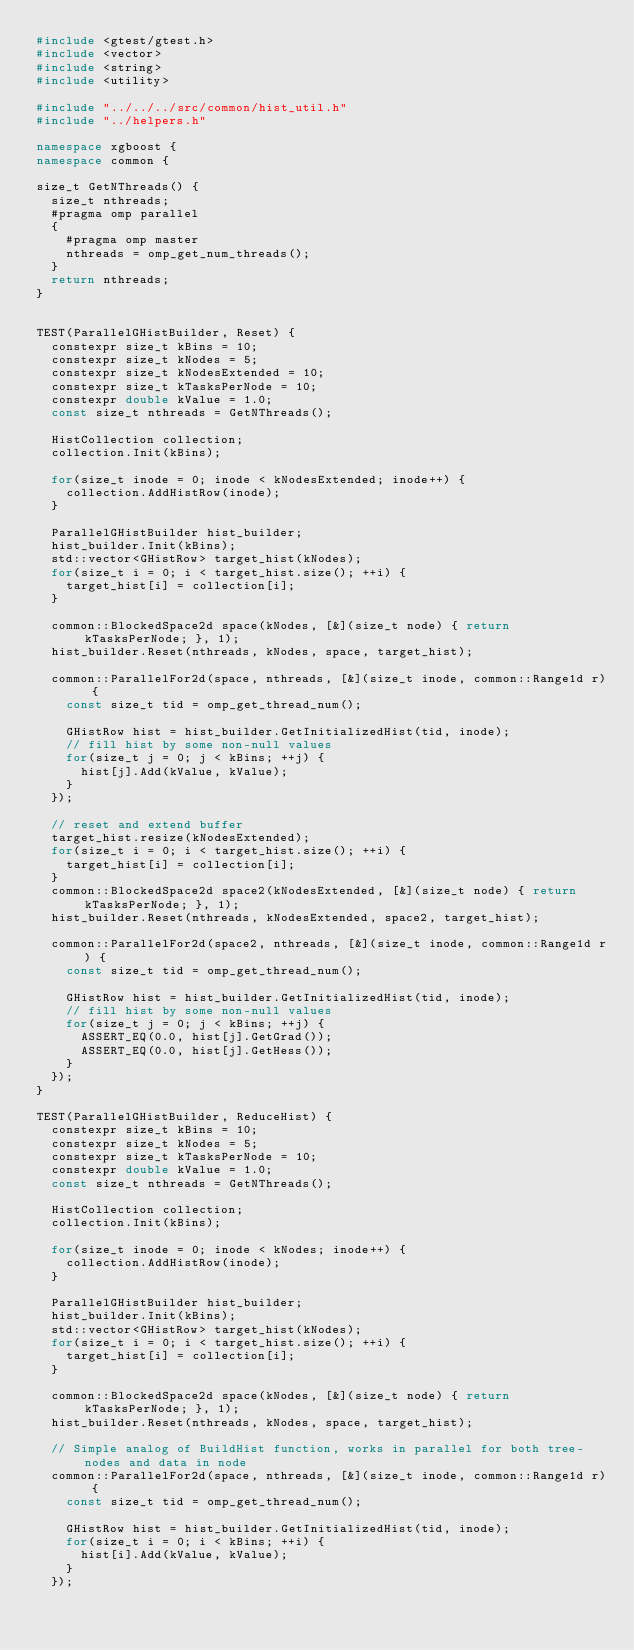Convert code to text. <code><loc_0><loc_0><loc_500><loc_500><_C++_>#include <gtest/gtest.h>
#include <vector>
#include <string>
#include <utility>

#include "../../../src/common/hist_util.h"
#include "../helpers.h"

namespace xgboost {
namespace common {

size_t GetNThreads() {
  size_t nthreads;
  #pragma omp parallel
  {
    #pragma omp master
    nthreads = omp_get_num_threads();
  }
  return nthreads;
}


TEST(ParallelGHistBuilder, Reset) {
  constexpr size_t kBins = 10;
  constexpr size_t kNodes = 5;
  constexpr size_t kNodesExtended = 10;
  constexpr size_t kTasksPerNode = 10;
  constexpr double kValue = 1.0;
  const size_t nthreads = GetNThreads();

  HistCollection collection;
  collection.Init(kBins);

  for(size_t inode = 0; inode < kNodesExtended; inode++) {
    collection.AddHistRow(inode);
  }

  ParallelGHistBuilder hist_builder;
  hist_builder.Init(kBins);
  std::vector<GHistRow> target_hist(kNodes);
  for(size_t i = 0; i < target_hist.size(); ++i) {
    target_hist[i] = collection[i];
  }

  common::BlockedSpace2d space(kNodes, [&](size_t node) { return kTasksPerNode; }, 1);
  hist_builder.Reset(nthreads, kNodes, space, target_hist);

  common::ParallelFor2d(space, nthreads, [&](size_t inode, common::Range1d r) {
    const size_t tid = omp_get_thread_num();

    GHistRow hist = hist_builder.GetInitializedHist(tid, inode);
    // fill hist by some non-null values
    for(size_t j = 0; j < kBins; ++j) {
      hist[j].Add(kValue, kValue);
    }
  });

  // reset and extend buffer
  target_hist.resize(kNodesExtended);
  for(size_t i = 0; i < target_hist.size(); ++i) {
    target_hist[i] = collection[i];
  }
  common::BlockedSpace2d space2(kNodesExtended, [&](size_t node) { return kTasksPerNode; }, 1);
  hist_builder.Reset(nthreads, kNodesExtended, space2, target_hist);

  common::ParallelFor2d(space2, nthreads, [&](size_t inode, common::Range1d r) {
    const size_t tid = omp_get_thread_num();

    GHistRow hist = hist_builder.GetInitializedHist(tid, inode);
    // fill hist by some non-null values
    for(size_t j = 0; j < kBins; ++j) {
      ASSERT_EQ(0.0, hist[j].GetGrad());
      ASSERT_EQ(0.0, hist[j].GetHess());
    }
  });
}

TEST(ParallelGHistBuilder, ReduceHist) {
  constexpr size_t kBins = 10;
  constexpr size_t kNodes = 5;
  constexpr size_t kTasksPerNode = 10;
  constexpr double kValue = 1.0;
  const size_t nthreads = GetNThreads();

  HistCollection collection;
  collection.Init(kBins);

  for(size_t inode = 0; inode < kNodes; inode++) {
    collection.AddHistRow(inode);
  }

  ParallelGHistBuilder hist_builder;
  hist_builder.Init(kBins);
  std::vector<GHistRow> target_hist(kNodes);
  for(size_t i = 0; i < target_hist.size(); ++i) {
    target_hist[i] = collection[i];
  }

  common::BlockedSpace2d space(kNodes, [&](size_t node) { return kTasksPerNode; }, 1);
  hist_builder.Reset(nthreads, kNodes, space, target_hist);

  // Simple analog of BuildHist function, works in parallel for both tree-nodes and data in node
  common::ParallelFor2d(space, nthreads, [&](size_t inode, common::Range1d r) {
    const size_t tid = omp_get_thread_num();

    GHistRow hist = hist_builder.GetInitializedHist(tid, inode);
    for(size_t i = 0; i < kBins; ++i) {
      hist[i].Add(kValue, kValue);
    }
  });
</code> 